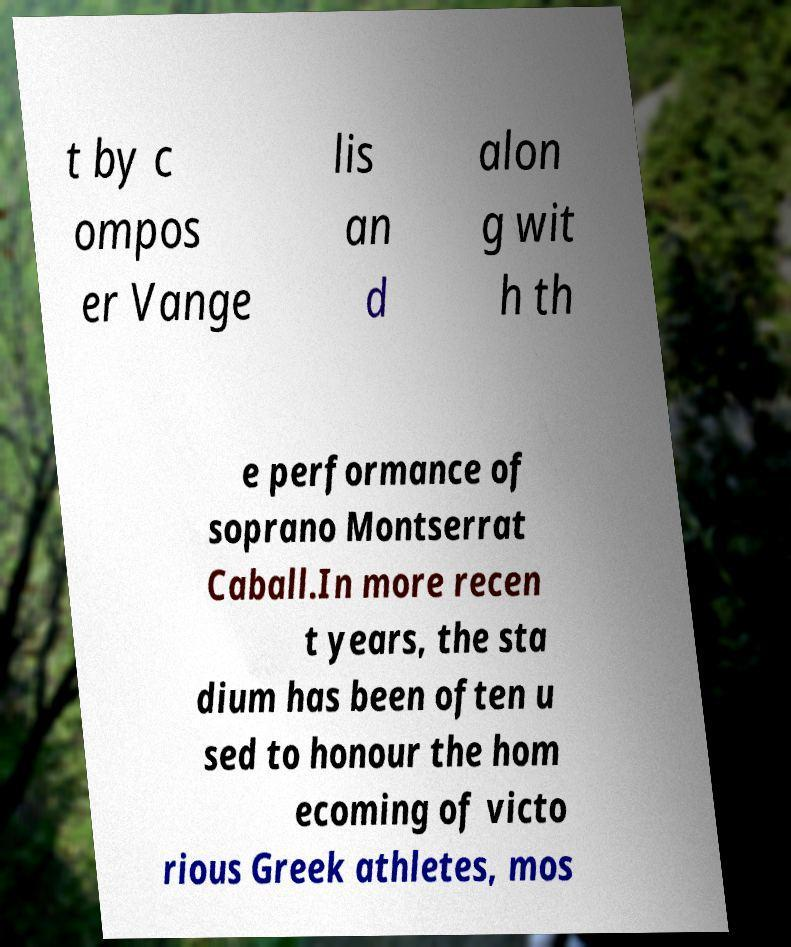Could you assist in decoding the text presented in this image and type it out clearly? t by c ompos er Vange lis an d alon g wit h th e performance of soprano Montserrat Caball.In more recen t years, the sta dium has been often u sed to honour the hom ecoming of victo rious Greek athletes, mos 